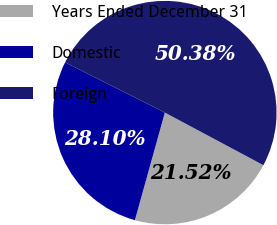Convert chart to OTSL. <chart><loc_0><loc_0><loc_500><loc_500><pie_chart><fcel>Years Ended December 31<fcel>Domestic<fcel>Foreign<nl><fcel>21.52%<fcel>28.1%<fcel>50.38%<nl></chart> 